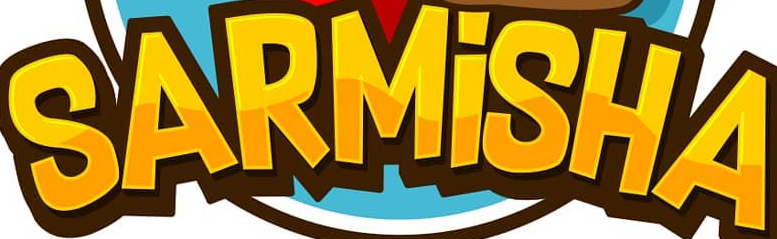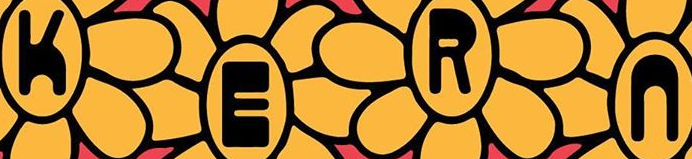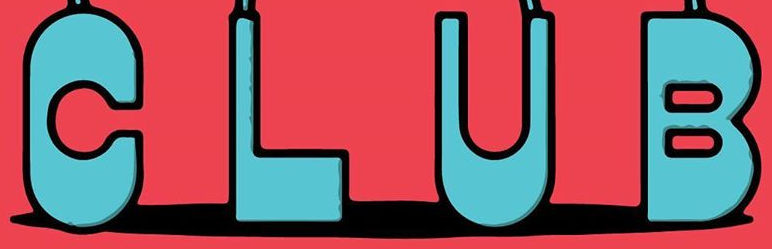Transcribe the words shown in these images in order, separated by a semicolon. SARMİSHA; KERn; CLUB 